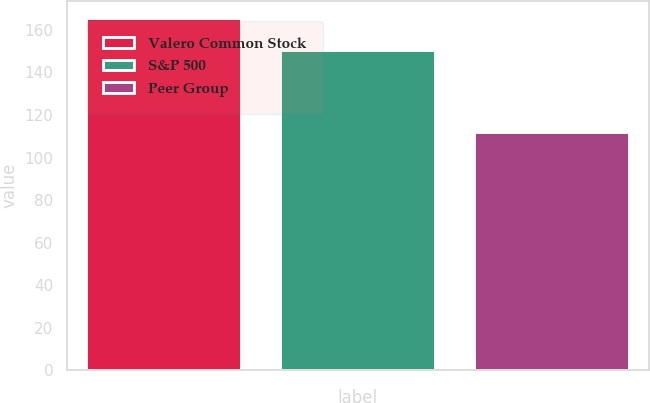<chart> <loc_0><loc_0><loc_500><loc_500><bar_chart><fcel>Valero Common Stock<fcel>S&P 500<fcel>Peer Group<nl><fcel>165.4<fcel>150.51<fcel>111.98<nl></chart> 